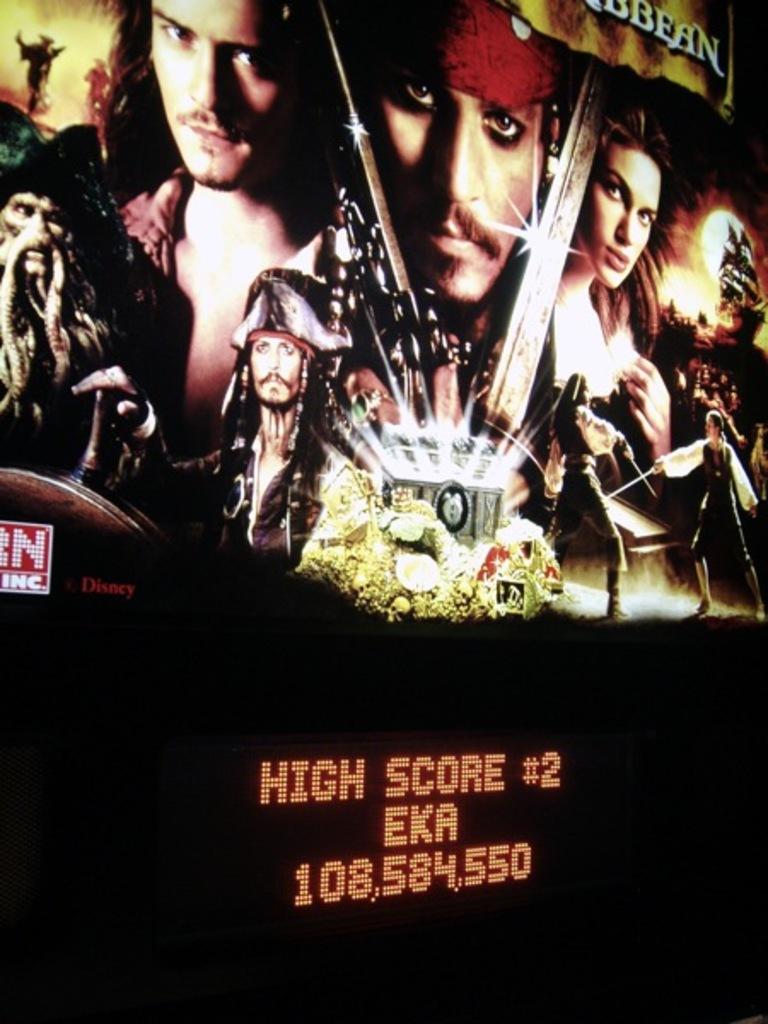What is the 2nd highest score?
Offer a very short reply. 108,584,550. 